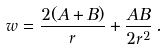<formula> <loc_0><loc_0><loc_500><loc_500>w = \frac { 2 ( A + B ) } { r } + \frac { A B } { 2 r ^ { 2 } } \, .</formula> 